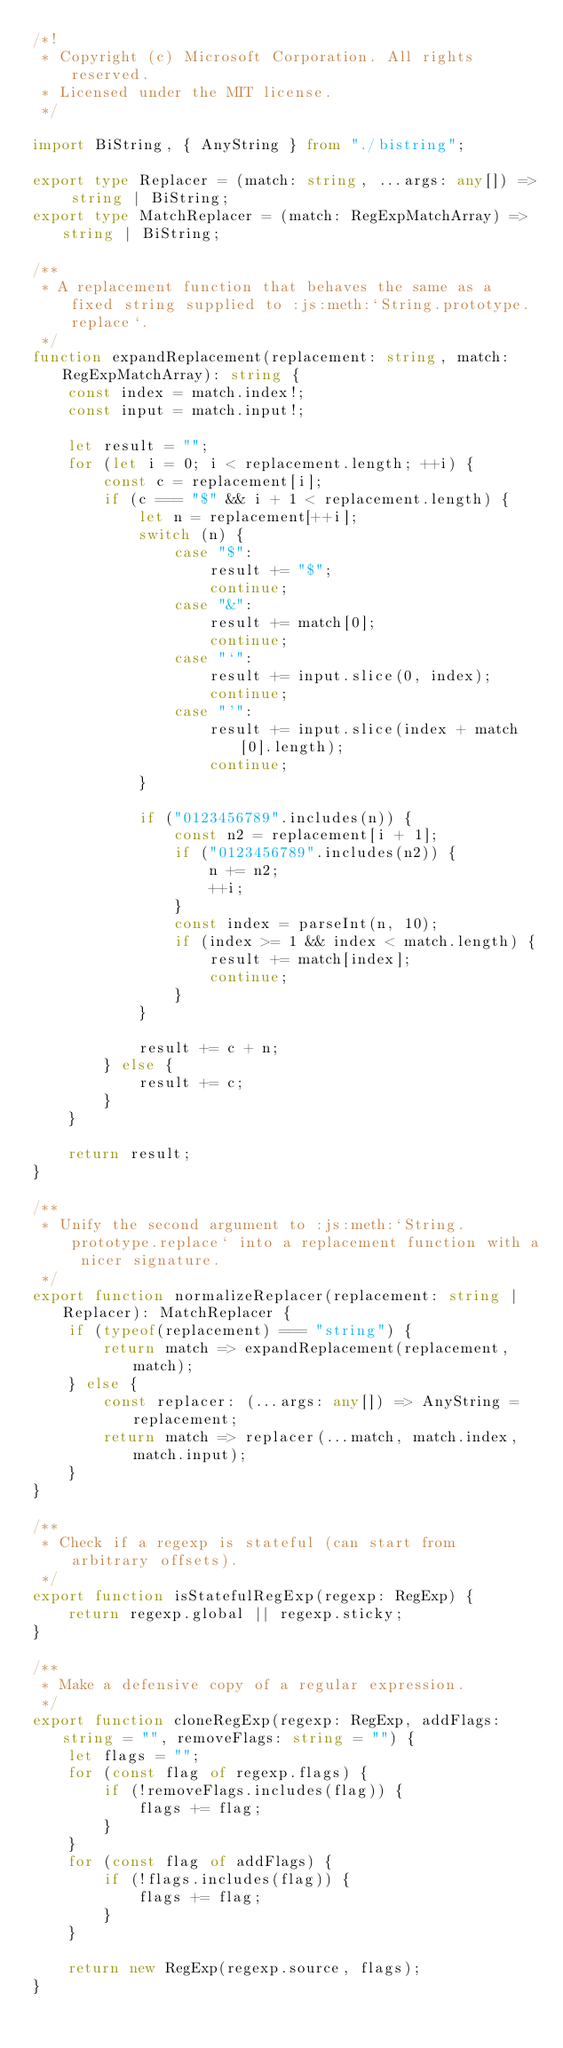<code> <loc_0><loc_0><loc_500><loc_500><_TypeScript_>/*!
 * Copyright (c) Microsoft Corporation. All rights reserved.
 * Licensed under the MIT license.
 */

import BiString, { AnyString } from "./bistring";

export type Replacer = (match: string, ...args: any[]) => string | BiString;
export type MatchReplacer = (match: RegExpMatchArray) => string | BiString;

/**
 * A replacement function that behaves the same as a fixed string supplied to :js:meth:`String.prototype.replace`.
 */
function expandReplacement(replacement: string, match: RegExpMatchArray): string {
    const index = match.index!;
    const input = match.input!;

    let result = "";
    for (let i = 0; i < replacement.length; ++i) {
        const c = replacement[i];
        if (c === "$" && i + 1 < replacement.length) {
            let n = replacement[++i];
            switch (n) {
                case "$":
                    result += "$";
                    continue;
                case "&":
                    result += match[0];
                    continue;
                case "`":
                    result += input.slice(0, index);
                    continue;
                case "'":
                    result += input.slice(index + match[0].length);
                    continue;
            }

            if ("0123456789".includes(n)) {
                const n2 = replacement[i + 1];
                if ("0123456789".includes(n2)) {
                    n += n2;
                    ++i;
                }
                const index = parseInt(n, 10);
                if (index >= 1 && index < match.length) {
                    result += match[index];
                    continue;
                }
            }

            result += c + n;
        } else {
            result += c;
        }
    }

    return result;
}

/**
 * Unify the second argument to :js:meth:`String.prototype.replace` into a replacement function with a nicer signature.
 */
export function normalizeReplacer(replacement: string | Replacer): MatchReplacer {
    if (typeof(replacement) === "string") {
        return match => expandReplacement(replacement, match);
    } else {
        const replacer: (...args: any[]) => AnyString = replacement;
        return match => replacer(...match, match.index, match.input);
    }
}

/**
 * Check if a regexp is stateful (can start from arbitrary offsets).
 */
export function isStatefulRegExp(regexp: RegExp) {
    return regexp.global || regexp.sticky;
}

/**
 * Make a defensive copy of a regular expression.
 */
export function cloneRegExp(regexp: RegExp, addFlags: string = "", removeFlags: string = "") {
    let flags = "";
    for (const flag of regexp.flags) {
        if (!removeFlags.includes(flag)) {
            flags += flag;
        }
    }
    for (const flag of addFlags) {
        if (!flags.includes(flag)) {
            flags += flag;
        }
    }

    return new RegExp(regexp.source, flags);
}
</code> 